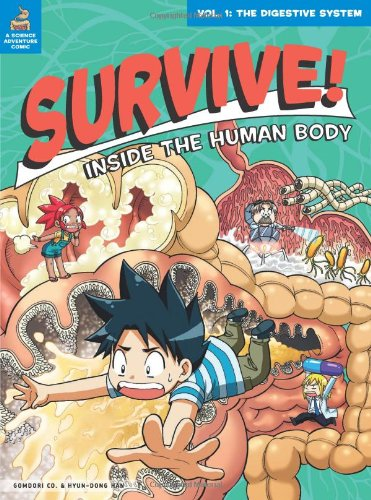Is this book related to Arts & Photography? No, this book isn't categorized under Arts & Photography. It's best described as a children's educational book with a focus on science and biology, particularly the human body. 